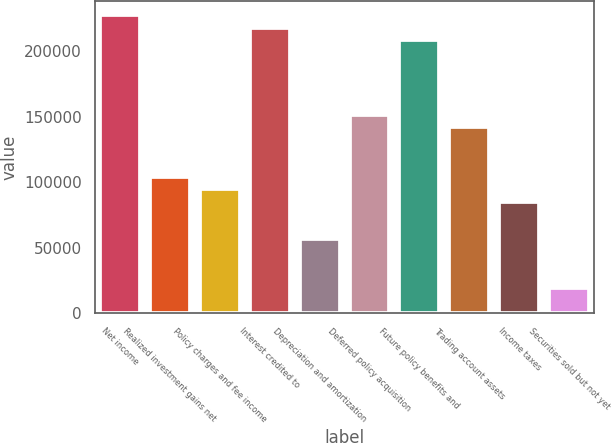Convert chart to OTSL. <chart><loc_0><loc_0><loc_500><loc_500><bar_chart><fcel>Net income<fcel>Realized investment gains net<fcel>Policy charges and fee income<fcel>Interest credited to<fcel>Depreciation and amortization<fcel>Deferred policy acquisition<fcel>Future policy benefits and<fcel>Trading account assets<fcel>Income taxes<fcel>Securities sold but not yet<nl><fcel>227141<fcel>104116<fcel>94653<fcel>217677<fcel>56799.4<fcel>151433<fcel>208214<fcel>141970<fcel>85189.6<fcel>18945.8<nl></chart> 